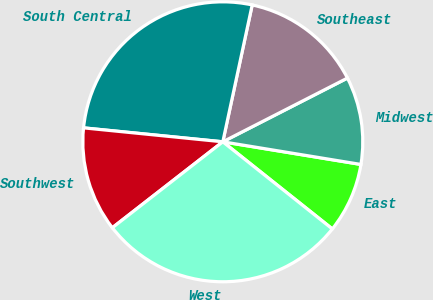<chart> <loc_0><loc_0><loc_500><loc_500><pie_chart><fcel>East<fcel>Midwest<fcel>Southeast<fcel>South Central<fcel>Southwest<fcel>West<nl><fcel>8.11%<fcel>10.11%<fcel>14.11%<fcel>26.78%<fcel>12.11%<fcel>28.78%<nl></chart> 